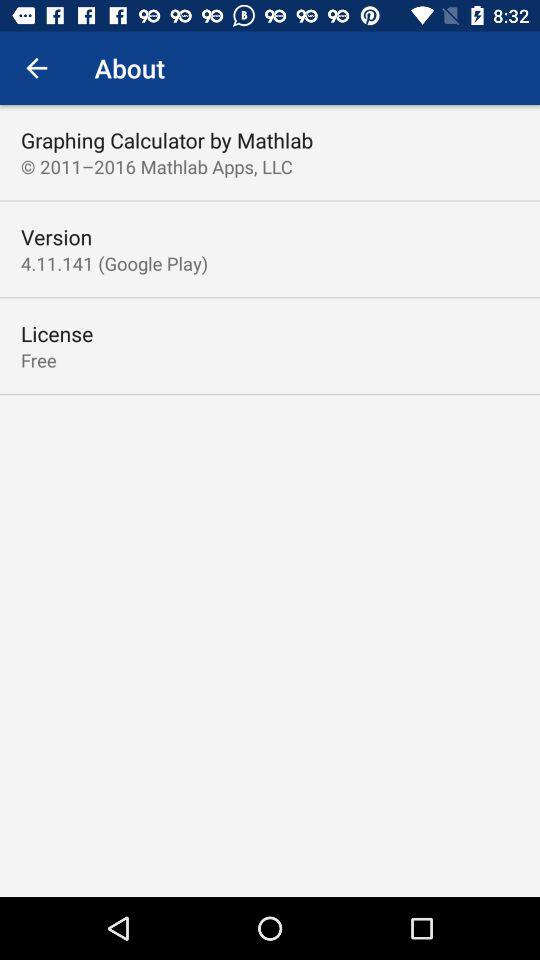What is the cost of the license? The license is free of cost. 